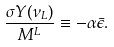Convert formula to latex. <formula><loc_0><loc_0><loc_500><loc_500>\frac { \sigma Y ( { \nu _ { L } } ) } { M ^ { L } } \equiv - \alpha \bar { \epsilon } .</formula> 